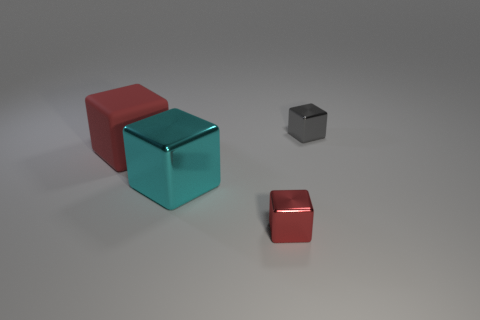Are there fewer metal objects than red things?
Your answer should be compact. No. What is the color of the tiny metallic cube that is in front of the red object behind the cyan shiny cube?
Ensure brevity in your answer.  Red. What material is the cyan object that is the same shape as the tiny red metallic object?
Ensure brevity in your answer.  Metal. What number of matte things are small cylinders or cyan things?
Offer a very short reply. 0. Is the material of the small cube that is behind the cyan block the same as the block in front of the large cyan metallic block?
Make the answer very short. Yes. Are any large cyan objects visible?
Provide a short and direct response. Yes. Does the tiny object on the left side of the tiny gray metal object have the same shape as the big thing that is on the left side of the big cyan cube?
Offer a terse response. Yes. Is there a tiny cylinder that has the same material as the cyan cube?
Make the answer very short. No. Does the big object that is on the right side of the large red matte object have the same material as the large red object?
Your answer should be very brief. No. Are there more cyan objects that are left of the rubber cube than tiny objects that are left of the small gray block?
Give a very brief answer. No. 